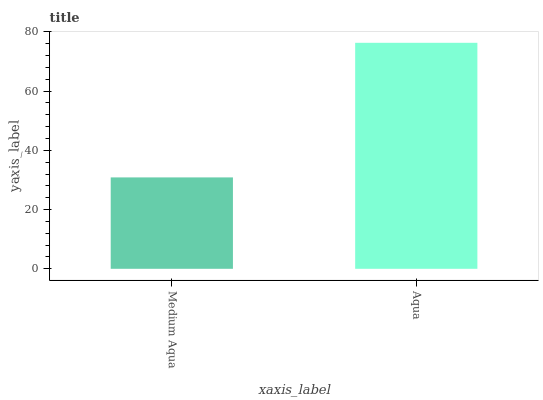Is Medium Aqua the minimum?
Answer yes or no. Yes. Is Aqua the maximum?
Answer yes or no. Yes. Is Aqua the minimum?
Answer yes or no. No. Is Aqua greater than Medium Aqua?
Answer yes or no. Yes. Is Medium Aqua less than Aqua?
Answer yes or no. Yes. Is Medium Aqua greater than Aqua?
Answer yes or no. No. Is Aqua less than Medium Aqua?
Answer yes or no. No. Is Aqua the high median?
Answer yes or no. Yes. Is Medium Aqua the low median?
Answer yes or no. Yes. Is Medium Aqua the high median?
Answer yes or no. No. Is Aqua the low median?
Answer yes or no. No. 